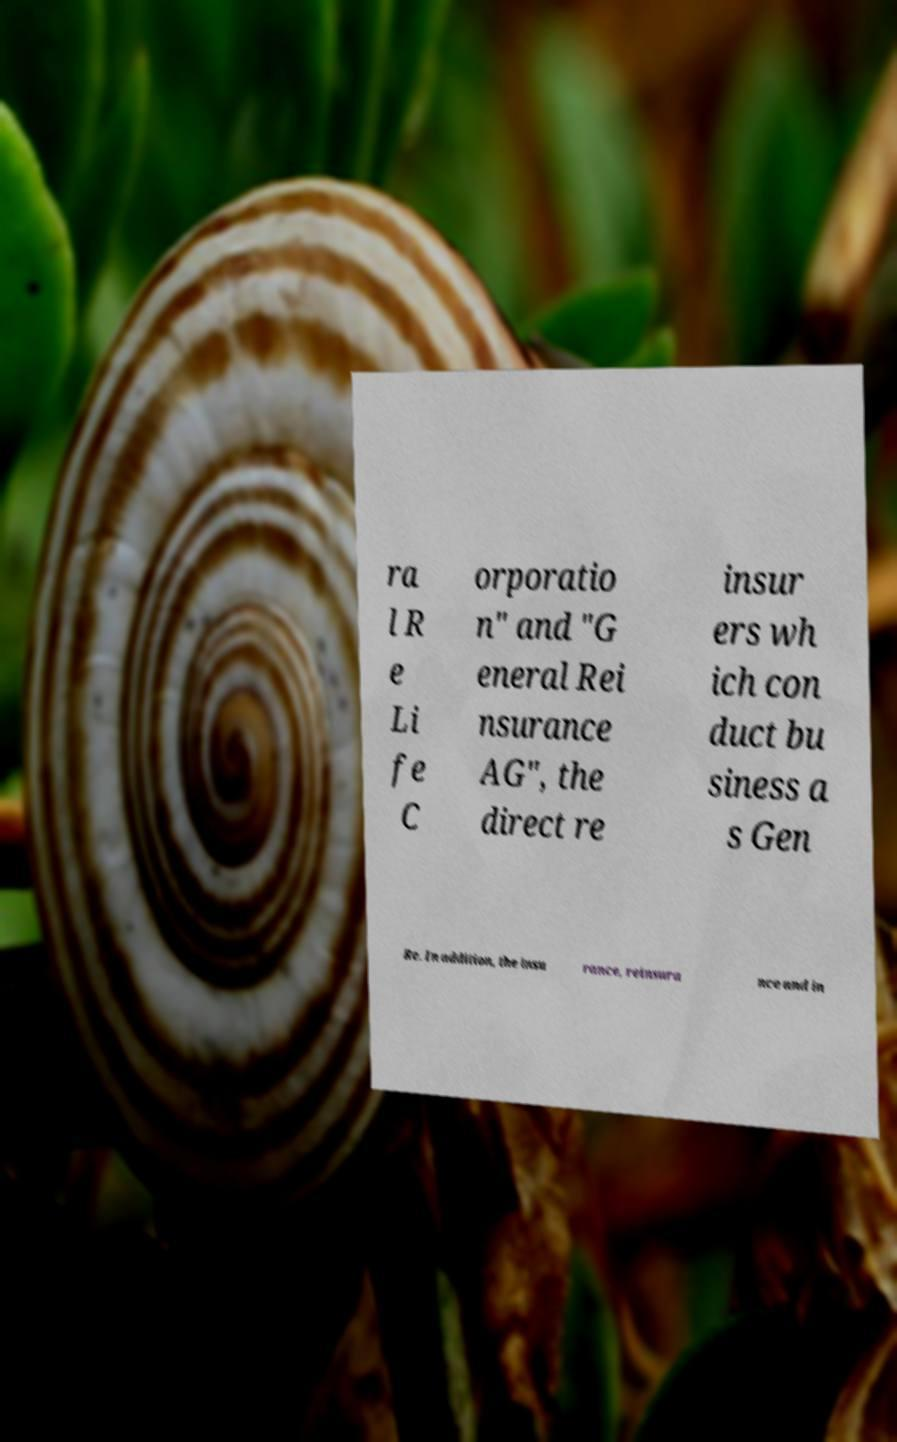Please read and relay the text visible in this image. What does it say? ra l R e Li fe C orporatio n" and "G eneral Rei nsurance AG", the direct re insur ers wh ich con duct bu siness a s Gen Re. In addition, the insu rance, reinsura nce and in 